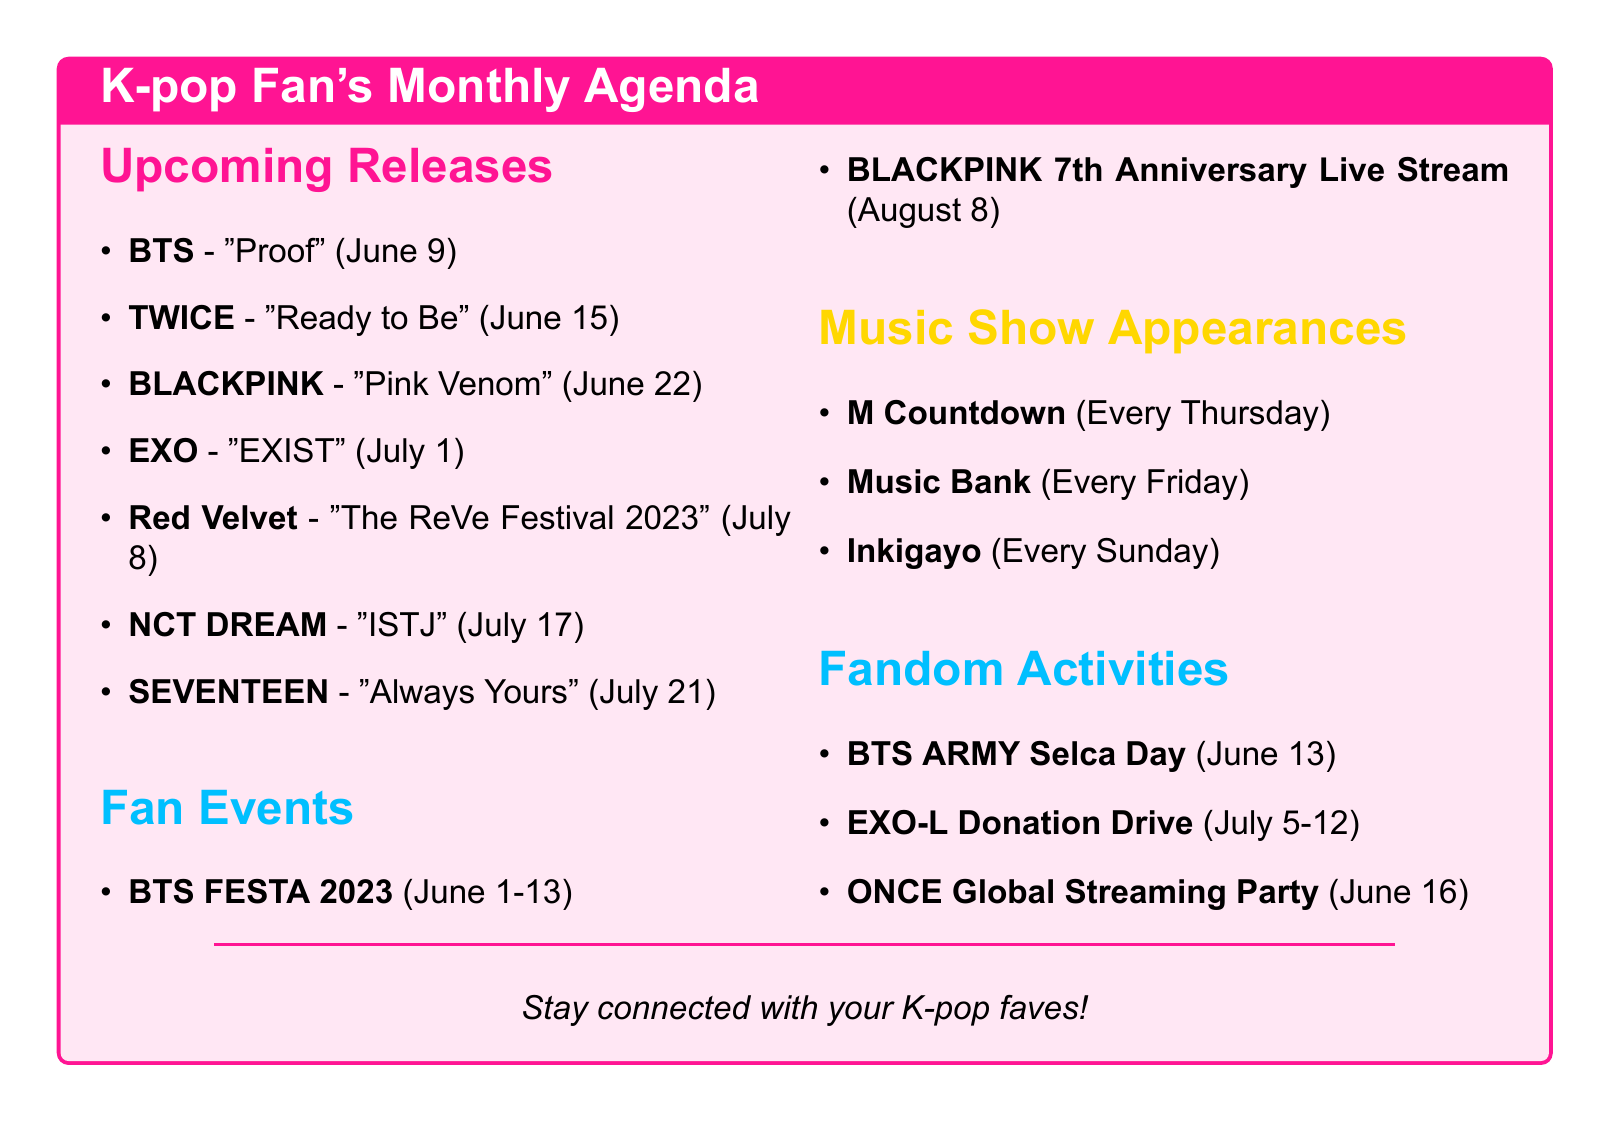What is the title of BLACKPINK's upcoming release? The title of BLACKPINK's upcoming release is found under the Upcoming Releases section.
Answer: Pink Venom When is the comeback date for EXO? EXO's comeback date can be found in the Upcoming Releases section along with other artist's dates.
Answer: July 1, 2023 What type of album is Red Velvet releasing? The type of album for Red Velvet can be derived from the release details in the Upcoming Releases section.
Answer: Mini Album What fandom activity is scheduled for June 13? The scheduled activity can be identified in the Fandom Activities section of the document.
Answer: BTS ARMY Selca Day Which artist has a release on July 21? This information is available in the Upcoming Releases section, listing artist names and their comeback dates.
Answer: SEVENTEEN How many fan events are listed in the document? The total number of fan events can be counted from the Fan Events section.
Answer: 2 On what day do music shows like M Countdown occur? M Countdown's schedule is explicitly stated in the Music Show Appearances section.
Answer: Every Thursday What is the description for the BTS FESTA 2023 event? The description can be retrieved from the Fan Events section detailing each event.
Answer: Annual celebration of BTS' debut anniversary 